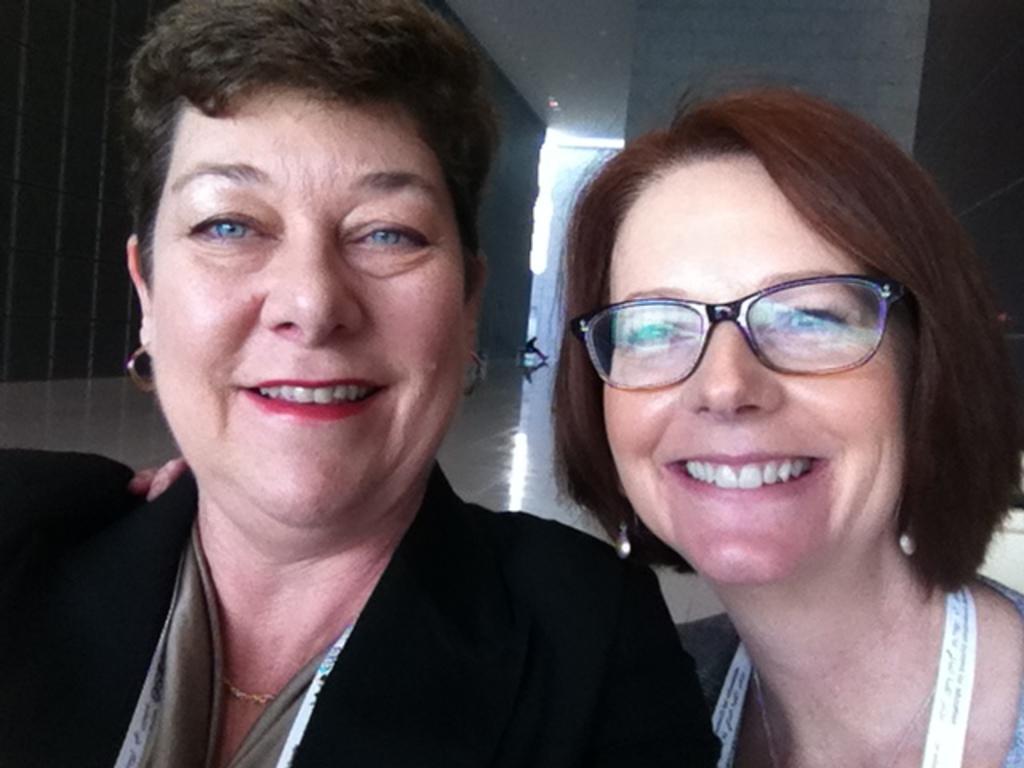How would you summarize this image in a sentence or two? In this picture we can see two women are smiling in the front, a woman on the right side is wearing spectacles, in the background there is a wall. 